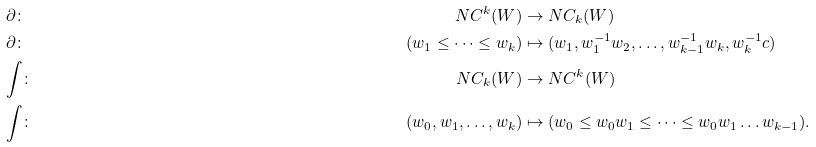<formula> <loc_0><loc_0><loc_500><loc_500>& \partial \colon & N C ^ { k } ( W ) & \rightarrow N C _ { k } ( W ) \\ & \partial \colon & ( w _ { 1 } \leq \dots \leq w _ { k } ) & \mapsto ( w _ { 1 } , w _ { 1 } ^ { - 1 } w _ { 2 } , \dots , w _ { k - 1 } ^ { - 1 } w _ { k } , w _ { k } ^ { - 1 } c ) \\ & \text {$\int$} \colon & N C _ { k } ( W ) & \rightarrow N C ^ { k } ( W ) \\ & \text {$\int$} \colon & ( w _ { 0 } , w _ { 1 } , \dots , w _ { k } ) & \mapsto ( w _ { 0 } \leq w _ { 0 } w _ { 1 } \leq \dots \leq w _ { 0 } w _ { 1 } \dots w _ { k - 1 } ) .</formula> 